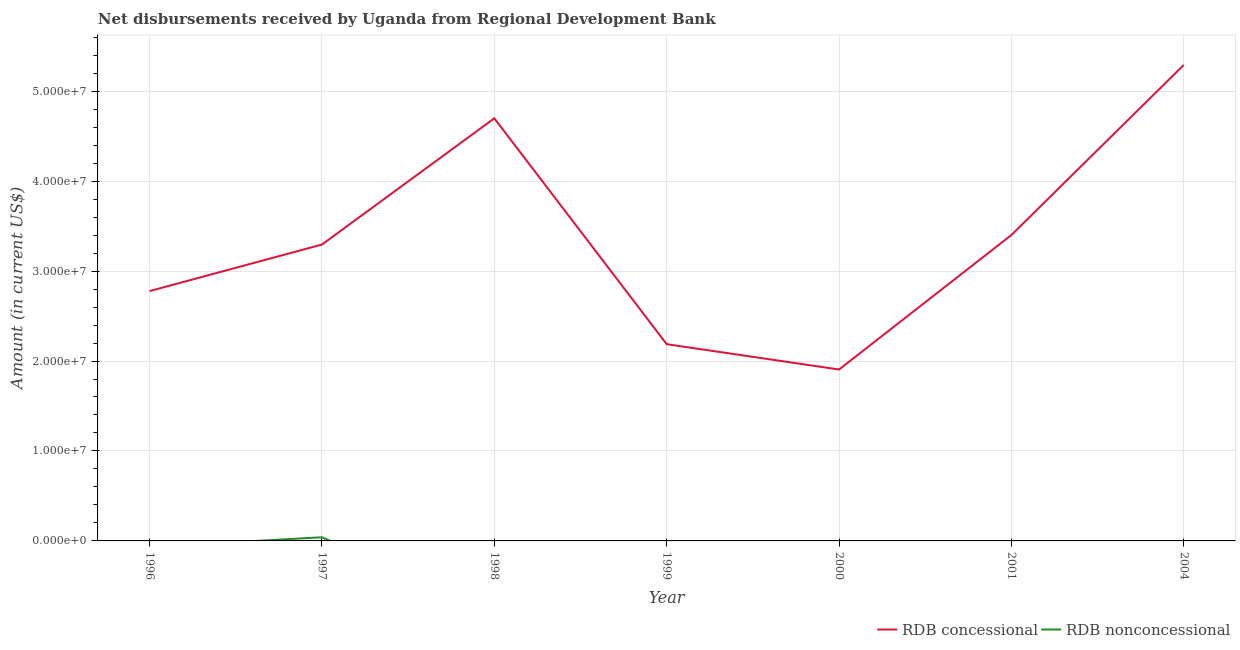How many different coloured lines are there?
Your answer should be compact. 2. What is the net concessional disbursements from rdb in 2000?
Give a very brief answer. 1.91e+07. Across all years, what is the maximum net non concessional disbursements from rdb?
Provide a succinct answer. 4.06e+05. Across all years, what is the minimum net concessional disbursements from rdb?
Make the answer very short. 1.91e+07. What is the total net non concessional disbursements from rdb in the graph?
Make the answer very short. 4.06e+05. What is the difference between the net concessional disbursements from rdb in 1997 and that in 1998?
Your response must be concise. -1.40e+07. What is the difference between the net non concessional disbursements from rdb in 1998 and the net concessional disbursements from rdb in 2001?
Make the answer very short. -3.40e+07. What is the average net concessional disbursements from rdb per year?
Your response must be concise. 3.37e+07. In the year 1997, what is the difference between the net concessional disbursements from rdb and net non concessional disbursements from rdb?
Make the answer very short. 3.25e+07. What is the ratio of the net concessional disbursements from rdb in 1996 to that in 1999?
Keep it short and to the point. 1.27. What is the difference between the highest and the second highest net concessional disbursements from rdb?
Your response must be concise. 5.94e+06. What is the difference between the highest and the lowest net non concessional disbursements from rdb?
Provide a succinct answer. 4.06e+05. Is the sum of the net concessional disbursements from rdb in 1999 and 2000 greater than the maximum net non concessional disbursements from rdb across all years?
Keep it short and to the point. Yes. Does the net non concessional disbursements from rdb monotonically increase over the years?
Keep it short and to the point. No. Is the net non concessional disbursements from rdb strictly greater than the net concessional disbursements from rdb over the years?
Make the answer very short. No. Is the net concessional disbursements from rdb strictly less than the net non concessional disbursements from rdb over the years?
Make the answer very short. No. How many years are there in the graph?
Your answer should be compact. 7. What is the difference between two consecutive major ticks on the Y-axis?
Your response must be concise. 1.00e+07. Are the values on the major ticks of Y-axis written in scientific E-notation?
Offer a very short reply. Yes. Does the graph contain any zero values?
Offer a terse response. Yes. Where does the legend appear in the graph?
Your answer should be very brief. Bottom right. How many legend labels are there?
Keep it short and to the point. 2. What is the title of the graph?
Give a very brief answer. Net disbursements received by Uganda from Regional Development Bank. Does "Urban" appear as one of the legend labels in the graph?
Keep it short and to the point. No. What is the label or title of the X-axis?
Give a very brief answer. Year. What is the Amount (in current US$) in RDB concessional in 1996?
Provide a succinct answer. 2.78e+07. What is the Amount (in current US$) of RDB nonconcessional in 1996?
Make the answer very short. 0. What is the Amount (in current US$) in RDB concessional in 1997?
Offer a terse response. 3.29e+07. What is the Amount (in current US$) in RDB nonconcessional in 1997?
Offer a terse response. 4.06e+05. What is the Amount (in current US$) in RDB concessional in 1998?
Your response must be concise. 4.70e+07. What is the Amount (in current US$) of RDB nonconcessional in 1998?
Make the answer very short. 0. What is the Amount (in current US$) in RDB concessional in 1999?
Provide a succinct answer. 2.19e+07. What is the Amount (in current US$) of RDB concessional in 2000?
Offer a very short reply. 1.91e+07. What is the Amount (in current US$) of RDB nonconcessional in 2000?
Your answer should be compact. 0. What is the Amount (in current US$) in RDB concessional in 2001?
Your response must be concise. 3.40e+07. What is the Amount (in current US$) of RDB nonconcessional in 2001?
Offer a terse response. 0. What is the Amount (in current US$) of RDB concessional in 2004?
Provide a short and direct response. 5.29e+07. Across all years, what is the maximum Amount (in current US$) of RDB concessional?
Provide a short and direct response. 5.29e+07. Across all years, what is the maximum Amount (in current US$) in RDB nonconcessional?
Provide a short and direct response. 4.06e+05. Across all years, what is the minimum Amount (in current US$) of RDB concessional?
Your answer should be very brief. 1.91e+07. Across all years, what is the minimum Amount (in current US$) of RDB nonconcessional?
Give a very brief answer. 0. What is the total Amount (in current US$) in RDB concessional in the graph?
Your response must be concise. 2.36e+08. What is the total Amount (in current US$) in RDB nonconcessional in the graph?
Your response must be concise. 4.06e+05. What is the difference between the Amount (in current US$) in RDB concessional in 1996 and that in 1997?
Make the answer very short. -5.17e+06. What is the difference between the Amount (in current US$) of RDB concessional in 1996 and that in 1998?
Keep it short and to the point. -1.92e+07. What is the difference between the Amount (in current US$) of RDB concessional in 1996 and that in 1999?
Ensure brevity in your answer.  5.90e+06. What is the difference between the Amount (in current US$) of RDB concessional in 1996 and that in 2000?
Give a very brief answer. 8.72e+06. What is the difference between the Amount (in current US$) of RDB concessional in 1996 and that in 2001?
Your response must be concise. -6.24e+06. What is the difference between the Amount (in current US$) of RDB concessional in 1996 and that in 2004?
Your answer should be compact. -2.51e+07. What is the difference between the Amount (in current US$) of RDB concessional in 1997 and that in 1998?
Give a very brief answer. -1.40e+07. What is the difference between the Amount (in current US$) of RDB concessional in 1997 and that in 1999?
Your response must be concise. 1.11e+07. What is the difference between the Amount (in current US$) of RDB concessional in 1997 and that in 2000?
Your answer should be compact. 1.39e+07. What is the difference between the Amount (in current US$) of RDB concessional in 1997 and that in 2001?
Offer a very short reply. -1.06e+06. What is the difference between the Amount (in current US$) of RDB concessional in 1997 and that in 2004?
Offer a terse response. -2.00e+07. What is the difference between the Amount (in current US$) of RDB concessional in 1998 and that in 1999?
Ensure brevity in your answer.  2.51e+07. What is the difference between the Amount (in current US$) in RDB concessional in 1998 and that in 2000?
Give a very brief answer. 2.79e+07. What is the difference between the Amount (in current US$) in RDB concessional in 1998 and that in 2001?
Offer a terse response. 1.30e+07. What is the difference between the Amount (in current US$) in RDB concessional in 1998 and that in 2004?
Your answer should be very brief. -5.94e+06. What is the difference between the Amount (in current US$) of RDB concessional in 1999 and that in 2000?
Your answer should be compact. 2.82e+06. What is the difference between the Amount (in current US$) of RDB concessional in 1999 and that in 2001?
Ensure brevity in your answer.  -1.21e+07. What is the difference between the Amount (in current US$) of RDB concessional in 1999 and that in 2004?
Provide a short and direct response. -3.10e+07. What is the difference between the Amount (in current US$) of RDB concessional in 2000 and that in 2001?
Ensure brevity in your answer.  -1.50e+07. What is the difference between the Amount (in current US$) in RDB concessional in 2000 and that in 2004?
Provide a short and direct response. -3.39e+07. What is the difference between the Amount (in current US$) in RDB concessional in 2001 and that in 2004?
Make the answer very short. -1.89e+07. What is the difference between the Amount (in current US$) in RDB concessional in 1996 and the Amount (in current US$) in RDB nonconcessional in 1997?
Provide a short and direct response. 2.74e+07. What is the average Amount (in current US$) in RDB concessional per year?
Your answer should be very brief. 3.37e+07. What is the average Amount (in current US$) in RDB nonconcessional per year?
Provide a succinct answer. 5.80e+04. In the year 1997, what is the difference between the Amount (in current US$) in RDB concessional and Amount (in current US$) in RDB nonconcessional?
Ensure brevity in your answer.  3.25e+07. What is the ratio of the Amount (in current US$) in RDB concessional in 1996 to that in 1997?
Offer a very short reply. 0.84. What is the ratio of the Amount (in current US$) in RDB concessional in 1996 to that in 1998?
Ensure brevity in your answer.  0.59. What is the ratio of the Amount (in current US$) in RDB concessional in 1996 to that in 1999?
Ensure brevity in your answer.  1.27. What is the ratio of the Amount (in current US$) in RDB concessional in 1996 to that in 2000?
Ensure brevity in your answer.  1.46. What is the ratio of the Amount (in current US$) in RDB concessional in 1996 to that in 2001?
Provide a succinct answer. 0.82. What is the ratio of the Amount (in current US$) of RDB concessional in 1996 to that in 2004?
Provide a short and direct response. 0.52. What is the ratio of the Amount (in current US$) of RDB concessional in 1997 to that in 1998?
Make the answer very short. 0.7. What is the ratio of the Amount (in current US$) of RDB concessional in 1997 to that in 1999?
Your answer should be very brief. 1.51. What is the ratio of the Amount (in current US$) of RDB concessional in 1997 to that in 2000?
Your answer should be compact. 1.73. What is the ratio of the Amount (in current US$) of RDB concessional in 1997 to that in 2001?
Your answer should be compact. 0.97. What is the ratio of the Amount (in current US$) in RDB concessional in 1997 to that in 2004?
Provide a succinct answer. 0.62. What is the ratio of the Amount (in current US$) in RDB concessional in 1998 to that in 1999?
Your answer should be compact. 2.15. What is the ratio of the Amount (in current US$) of RDB concessional in 1998 to that in 2000?
Ensure brevity in your answer.  2.47. What is the ratio of the Amount (in current US$) in RDB concessional in 1998 to that in 2001?
Keep it short and to the point. 1.38. What is the ratio of the Amount (in current US$) of RDB concessional in 1998 to that in 2004?
Provide a short and direct response. 0.89. What is the ratio of the Amount (in current US$) in RDB concessional in 1999 to that in 2000?
Offer a very short reply. 1.15. What is the ratio of the Amount (in current US$) of RDB concessional in 1999 to that in 2001?
Keep it short and to the point. 0.64. What is the ratio of the Amount (in current US$) of RDB concessional in 1999 to that in 2004?
Make the answer very short. 0.41. What is the ratio of the Amount (in current US$) of RDB concessional in 2000 to that in 2001?
Provide a succinct answer. 0.56. What is the ratio of the Amount (in current US$) in RDB concessional in 2000 to that in 2004?
Provide a succinct answer. 0.36. What is the ratio of the Amount (in current US$) of RDB concessional in 2001 to that in 2004?
Make the answer very short. 0.64. What is the difference between the highest and the second highest Amount (in current US$) in RDB concessional?
Offer a very short reply. 5.94e+06. What is the difference between the highest and the lowest Amount (in current US$) of RDB concessional?
Make the answer very short. 3.39e+07. What is the difference between the highest and the lowest Amount (in current US$) of RDB nonconcessional?
Keep it short and to the point. 4.06e+05. 